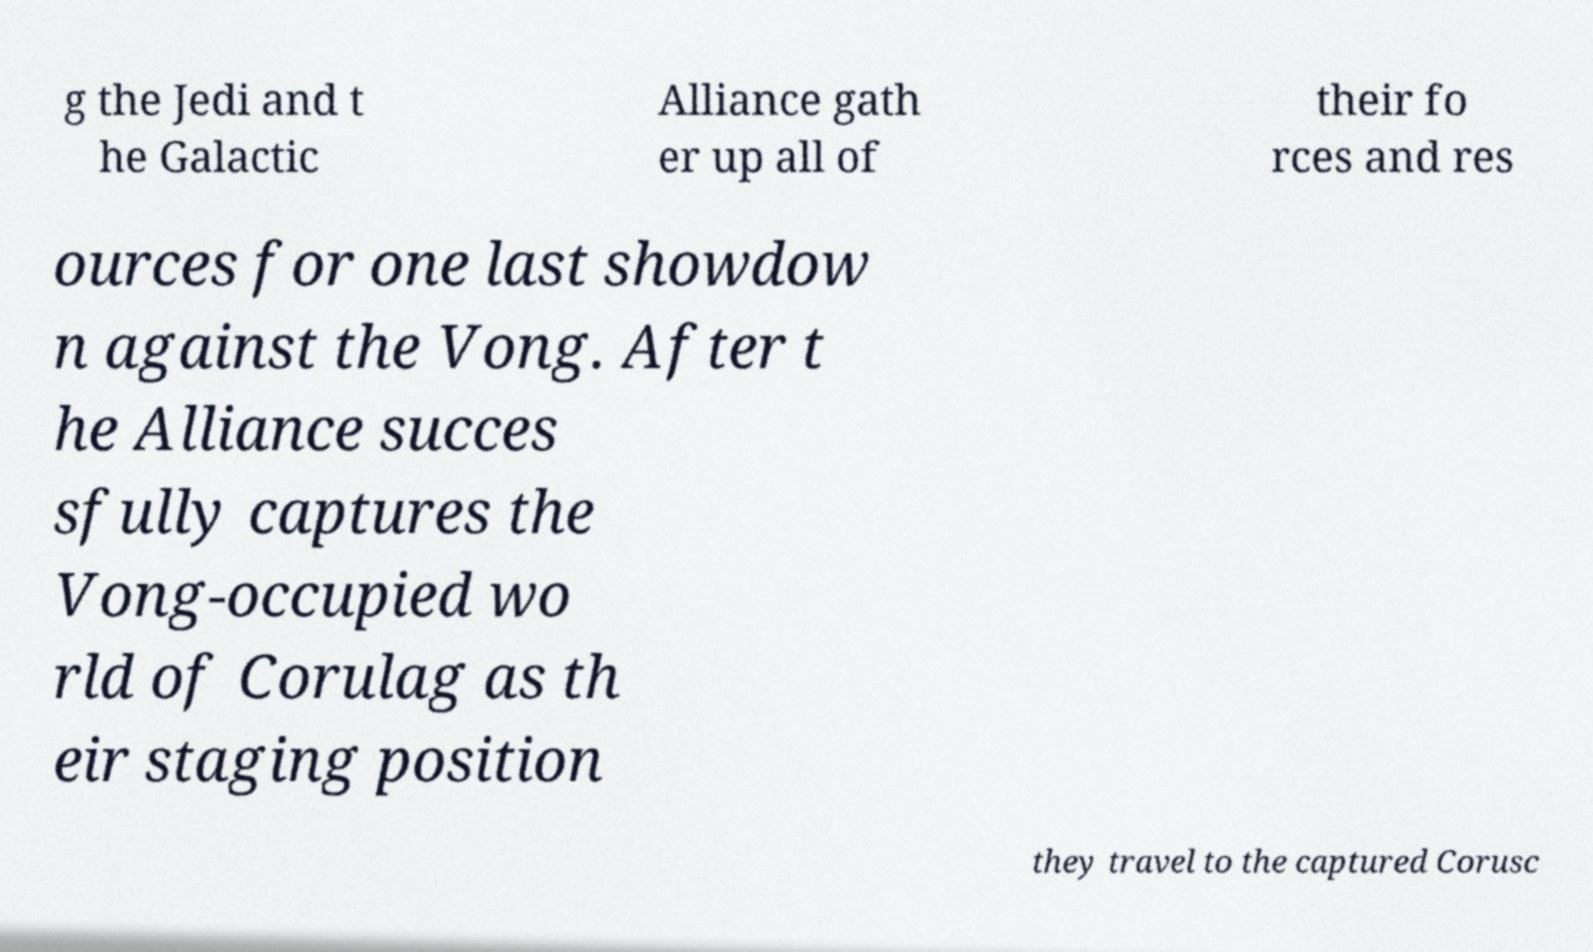For documentation purposes, I need the text within this image transcribed. Could you provide that? g the Jedi and t he Galactic Alliance gath er up all of their fo rces and res ources for one last showdow n against the Vong. After t he Alliance succes sfully captures the Vong-occupied wo rld of Corulag as th eir staging position they travel to the captured Corusc 